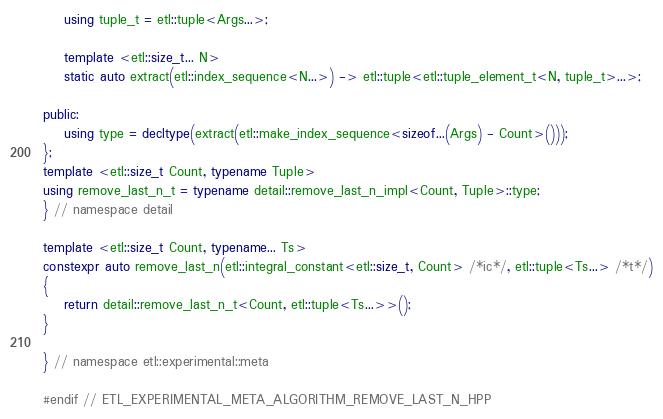<code> <loc_0><loc_0><loc_500><loc_500><_C++_>    using tuple_t = etl::tuple<Args...>;

    template <etl::size_t... N>
    static auto extract(etl::index_sequence<N...>) -> etl::tuple<etl::tuple_element_t<N, tuple_t>...>;

public:
    using type = decltype(extract(etl::make_index_sequence<sizeof...(Args) - Count>()));
};
template <etl::size_t Count, typename Tuple>
using remove_last_n_t = typename detail::remove_last_n_impl<Count, Tuple>::type;
} // namespace detail

template <etl::size_t Count, typename... Ts>
constexpr auto remove_last_n(etl::integral_constant<etl::size_t, Count> /*ic*/, etl::tuple<Ts...> /*t*/)
{
    return detail::remove_last_n_t<Count, etl::tuple<Ts...>>();
}

} // namespace etl::experimental::meta

#endif // ETL_EXPERIMENTAL_META_ALGORITHM_REMOVE_LAST_N_HPP
</code> 